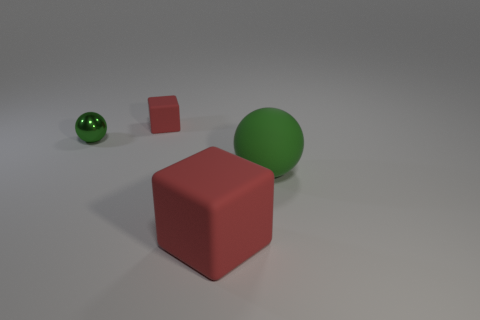There is a large matte ball; is it the same color as the small thing to the left of the tiny block?
Offer a very short reply. Yes. Are there the same number of big red things that are to the left of the tiny red thing and small blocks on the right side of the large green matte ball?
Offer a very short reply. Yes. There is a big thing that is in front of the rubber sphere; what is it made of?
Ensure brevity in your answer.  Rubber. How many things are either balls that are behind the big green rubber sphere or large green rubber spheres?
Ensure brevity in your answer.  2. What number of other things are the same shape as the metal thing?
Make the answer very short. 1. There is a green thing left of the big green rubber object; does it have the same shape as the big green thing?
Offer a terse response. Yes. There is a small red block; are there any matte cubes in front of it?
Provide a short and direct response. Yes. How many big objects are either purple metal spheres or green matte objects?
Keep it short and to the point. 1. Are the big red object and the tiny red block made of the same material?
Keep it short and to the point. Yes. What size is the other cube that is the same color as the tiny rubber cube?
Provide a succinct answer. Large. 